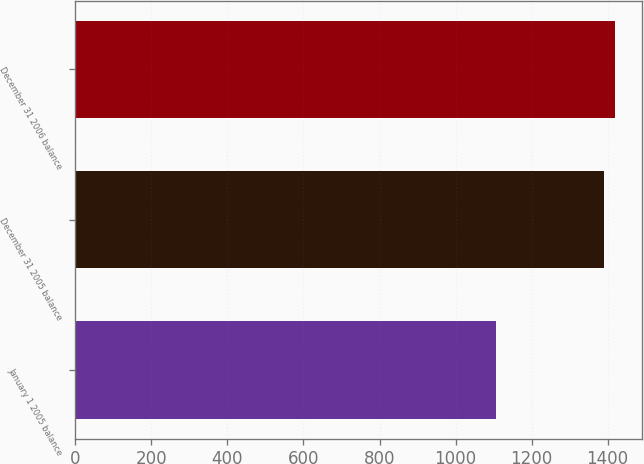Convert chart. <chart><loc_0><loc_0><loc_500><loc_500><bar_chart><fcel>January 1 2005 balance<fcel>December 31 2005 balance<fcel>December 31 2006 balance<nl><fcel>1107.6<fcel>1390.7<fcel>1419.14<nl></chart> 